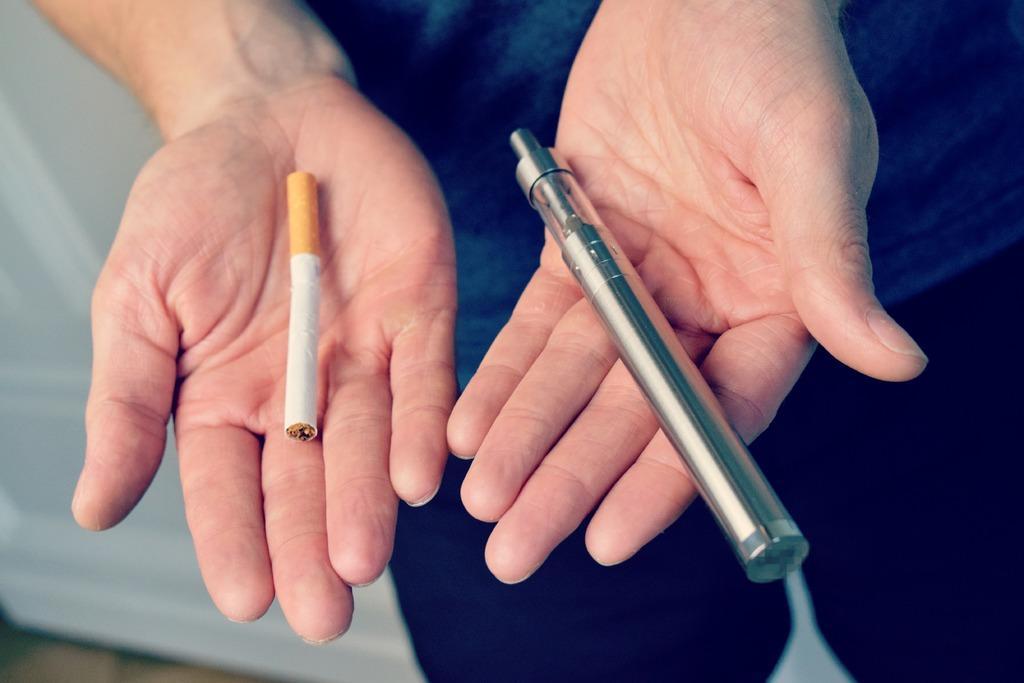Can you describe this image briefly? In this picture there is a person holding a cigarette and an object. In the background of the image it is white. 